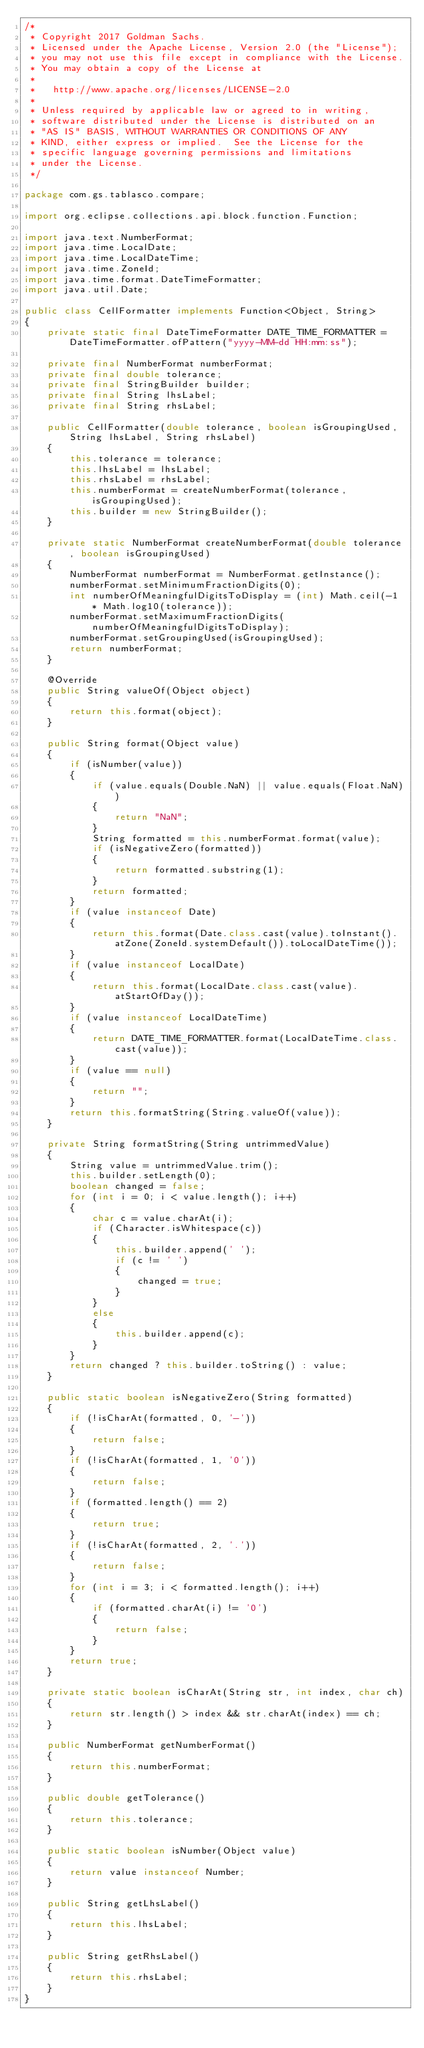<code> <loc_0><loc_0><loc_500><loc_500><_Java_>/*
 * Copyright 2017 Goldman Sachs.
 * Licensed under the Apache License, Version 2.0 (the "License");
 * you may not use this file except in compliance with the License.
 * You may obtain a copy of the License at
 *
 *   http://www.apache.org/licenses/LICENSE-2.0
 *
 * Unless required by applicable law or agreed to in writing,
 * software distributed under the License is distributed on an
 * "AS IS" BASIS, WITHOUT WARRANTIES OR CONDITIONS OF ANY
 * KIND, either express or implied.  See the License for the
 * specific language governing permissions and limitations
 * under the License.
 */

package com.gs.tablasco.compare;

import org.eclipse.collections.api.block.function.Function;

import java.text.NumberFormat;
import java.time.LocalDate;
import java.time.LocalDateTime;
import java.time.ZoneId;
import java.time.format.DateTimeFormatter;
import java.util.Date;

public class CellFormatter implements Function<Object, String>
{
    private static final DateTimeFormatter DATE_TIME_FORMATTER = DateTimeFormatter.ofPattern("yyyy-MM-dd HH:mm:ss");

    private final NumberFormat numberFormat;
    private final double tolerance;
    private final StringBuilder builder;
    private final String lhsLabel;
    private final String rhsLabel;

    public CellFormatter(double tolerance, boolean isGroupingUsed, String lhsLabel, String rhsLabel)
    {
        this.tolerance = tolerance;
        this.lhsLabel = lhsLabel;
        this.rhsLabel = rhsLabel;
        this.numberFormat = createNumberFormat(tolerance, isGroupingUsed);
        this.builder = new StringBuilder();
    }

    private static NumberFormat createNumberFormat(double tolerance, boolean isGroupingUsed)
    {
        NumberFormat numberFormat = NumberFormat.getInstance();
        numberFormat.setMinimumFractionDigits(0);
        int numberOfMeaningfulDigitsToDisplay = (int) Math.ceil(-1 * Math.log10(tolerance));
        numberFormat.setMaximumFractionDigits(numberOfMeaningfulDigitsToDisplay);
        numberFormat.setGroupingUsed(isGroupingUsed);
        return numberFormat;
    }

    @Override
    public String valueOf(Object object)
    {
        return this.format(object);
    }

    public String format(Object value)
    {
        if (isNumber(value))
        {
            if (value.equals(Double.NaN) || value.equals(Float.NaN))
            {
                return "NaN";
            }
            String formatted = this.numberFormat.format(value);
            if (isNegativeZero(formatted))
            {
                return formatted.substring(1);
            }
            return formatted;
        }
        if (value instanceof Date)
        {
            return this.format(Date.class.cast(value).toInstant().atZone(ZoneId.systemDefault()).toLocalDateTime());
        }
        if (value instanceof LocalDate)
        {
            return this.format(LocalDate.class.cast(value).atStartOfDay());
        }
        if (value instanceof LocalDateTime)
        {
            return DATE_TIME_FORMATTER.format(LocalDateTime.class.cast(value));
        }
        if (value == null)
        {
            return "";
        }
        return this.formatString(String.valueOf(value));
    }

    private String formatString(String untrimmedValue)
    {
        String value = untrimmedValue.trim();
        this.builder.setLength(0);
        boolean changed = false;
        for (int i = 0; i < value.length(); i++)
        {
            char c = value.charAt(i);
            if (Character.isWhitespace(c))
            {
                this.builder.append(' ');
                if (c != ' ')
                {
                    changed = true;
                }
            }
            else
            {
                this.builder.append(c);
            }
        }
        return changed ? this.builder.toString() : value;
    }

    public static boolean isNegativeZero(String formatted)
    {
        if (!isCharAt(formatted, 0, '-'))
        {
            return false;
        }
        if (!isCharAt(formatted, 1, '0'))
        {
            return false;
        }
        if (formatted.length() == 2)
        {
            return true;
        }
        if (!isCharAt(formatted, 2, '.'))
        {
            return false;
        }
        for (int i = 3; i < formatted.length(); i++)
        {
            if (formatted.charAt(i) != '0')
            {
                return false;
            }
        }
        return true;
    }

    private static boolean isCharAt(String str, int index, char ch)
    {
        return str.length() > index && str.charAt(index) == ch;
    }

    public NumberFormat getNumberFormat()
    {
        return this.numberFormat;
    }

    public double getTolerance()
    {
        return this.tolerance;
    }

    public static boolean isNumber(Object value)
    {
        return value instanceof Number;
    }

    public String getLhsLabel()
    {
        return this.lhsLabel;
    }

    public String getRhsLabel()
    {
        return this.rhsLabel;
    }
}
</code> 